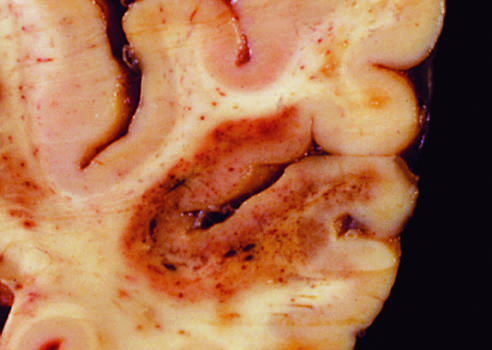s an infarct with punctate hemorrhages, consistent with ischemia-reperfusion injury, present in the temporal lobe?
Answer the question using a single word or phrase. Yes 